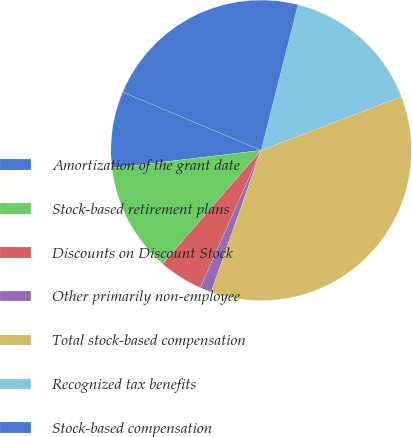Convert chart to OTSL. <chart><loc_0><loc_0><loc_500><loc_500><pie_chart><fcel>Amortization of the grant date<fcel>Stock-based retirement plans<fcel>Discounts on Discount Stock<fcel>Other primarily non-employee<fcel>Total stock-based compensation<fcel>Recognized tax benefits<fcel>Stock-based compensation<nl><fcel>8.24%<fcel>11.73%<fcel>4.74%<fcel>1.24%<fcel>36.22%<fcel>15.23%<fcel>22.6%<nl></chart> 